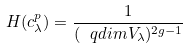<formula> <loc_0><loc_0><loc_500><loc_500>H ( c ^ { p } _ { \lambda } ) = \frac { 1 } { ( \ q d i m V _ { \lambda } ) ^ { 2 g - 1 } }</formula> 